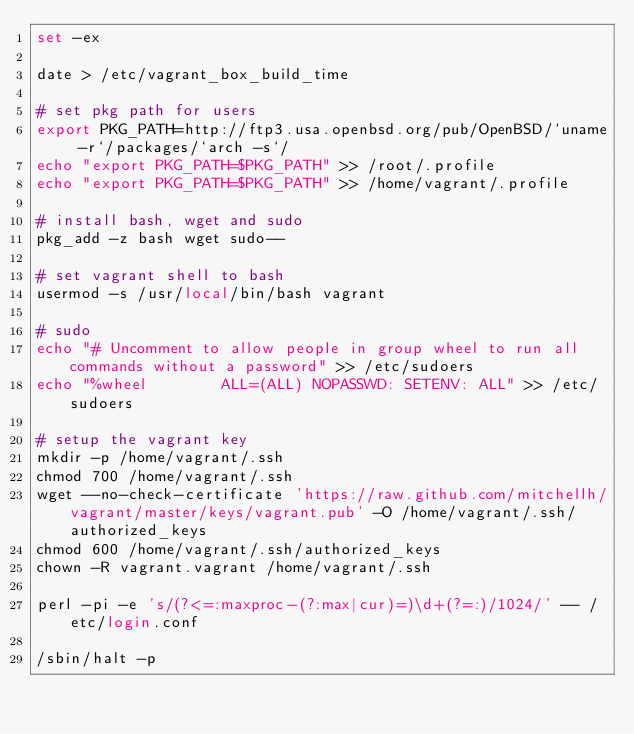Convert code to text. <code><loc_0><loc_0><loc_500><loc_500><_Bash_>set -ex

date > /etc/vagrant_box_build_time

# set pkg path for users
export PKG_PATH=http://ftp3.usa.openbsd.org/pub/OpenBSD/`uname -r`/packages/`arch -s`/
echo "export PKG_PATH=$PKG_PATH" >> /root/.profile
echo "export PKG_PATH=$PKG_PATH" >> /home/vagrant/.profile

# install bash, wget and sudo
pkg_add -z bash wget sudo--

# set vagrant shell to bash
usermod -s /usr/local/bin/bash vagrant

# sudo
echo "# Uncomment to allow people in group wheel to run all commands without a password" >> /etc/sudoers
echo "%wheel        ALL=(ALL) NOPASSWD: SETENV: ALL" >> /etc/sudoers

# setup the vagrant key
mkdir -p /home/vagrant/.ssh
chmod 700 /home/vagrant/.ssh
wget --no-check-certificate 'https://raw.github.com/mitchellh/vagrant/master/keys/vagrant.pub' -O /home/vagrant/.ssh/authorized_keys
chmod 600 /home/vagrant/.ssh/authorized_keys
chown -R vagrant.vagrant /home/vagrant/.ssh

perl -pi -e 's/(?<=:maxproc-(?:max|cur)=)\d+(?=:)/1024/' -- /etc/login.conf

/sbin/halt -p
</code> 